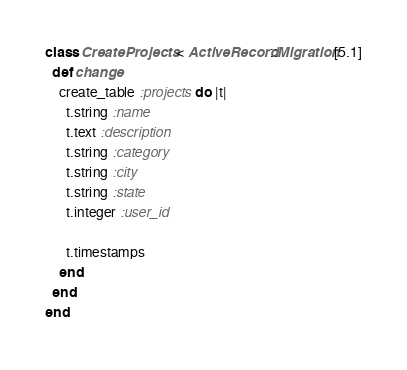Convert code to text. <code><loc_0><loc_0><loc_500><loc_500><_Ruby_>class CreateProjects < ActiveRecord::Migration[5.1]
  def change
    create_table :projects do |t|
      t.string :name
      t.text :description
      t.string :category
      t.string :city
      t.string :state
      t.integer :user_id

      t.timestamps
    end
  end
end
</code> 